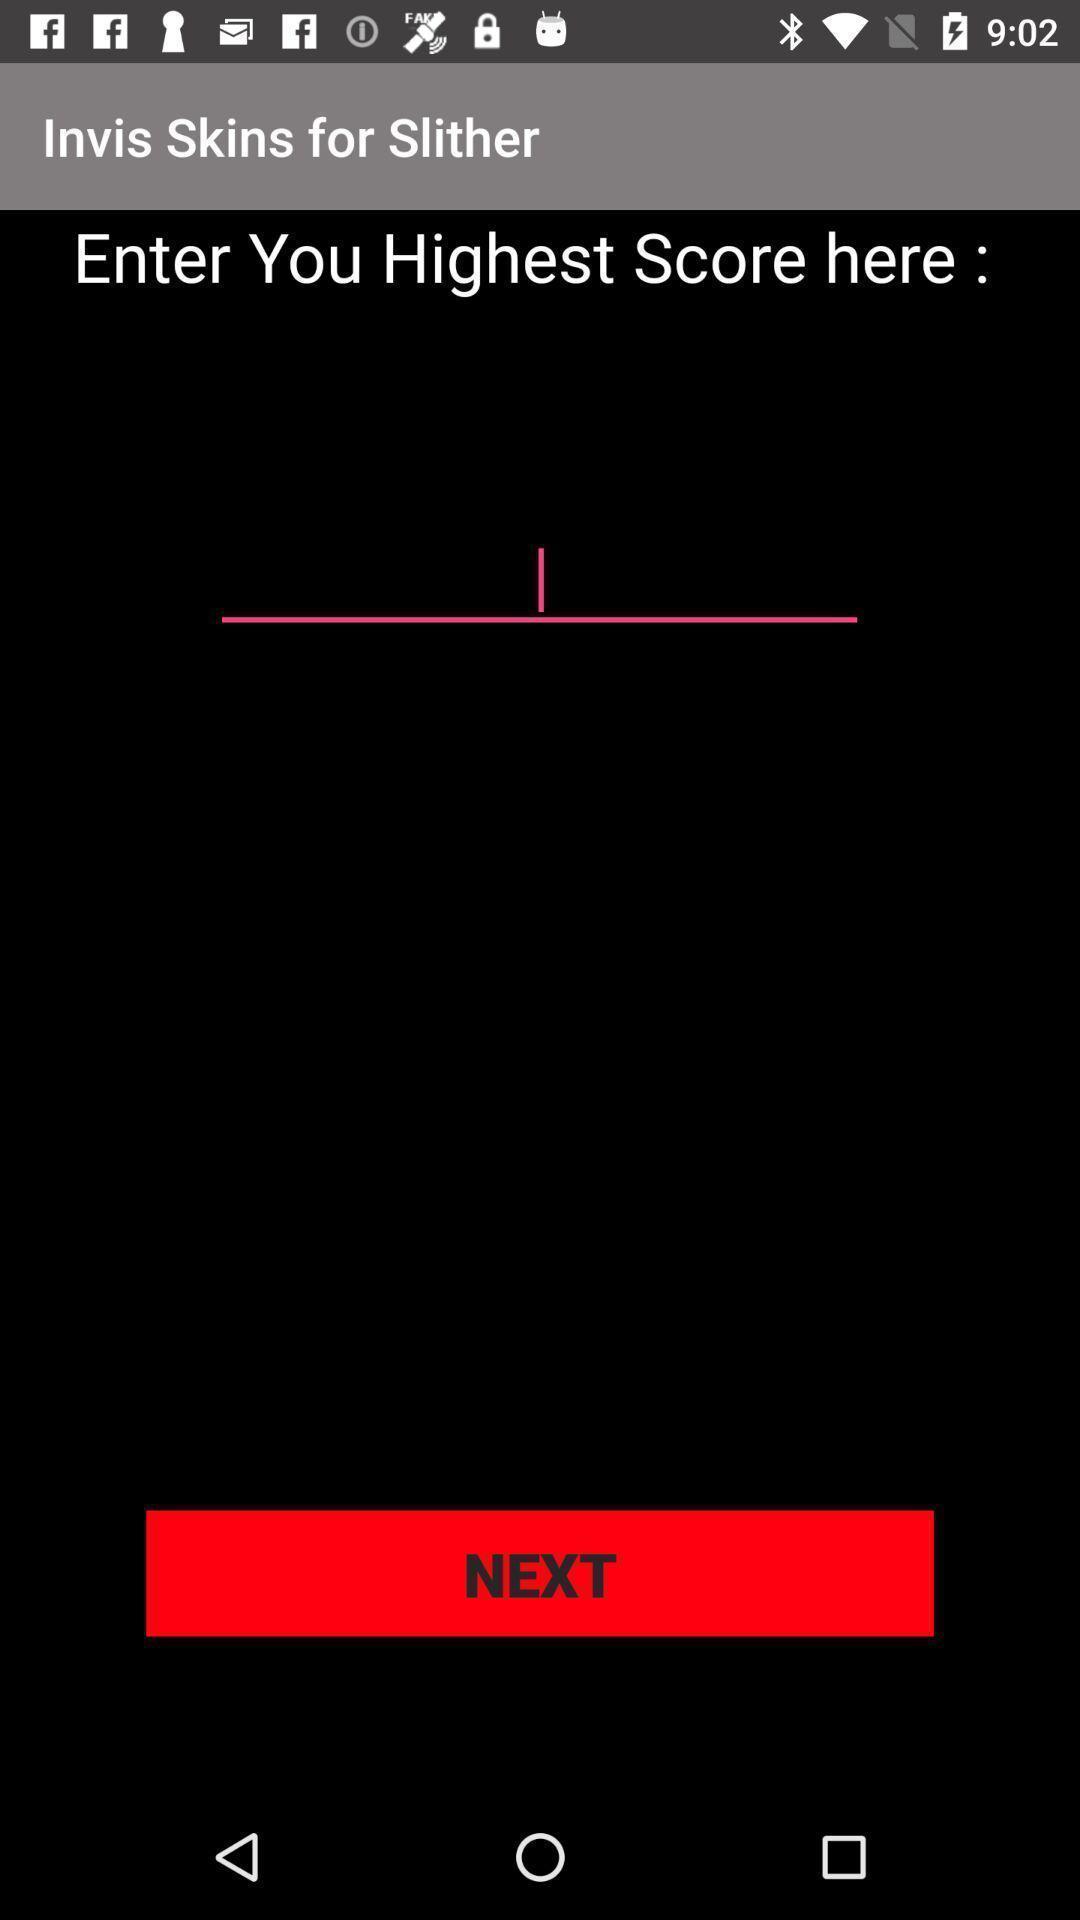Summarize the main components in this picture. Screen asking to enter a higher score. 